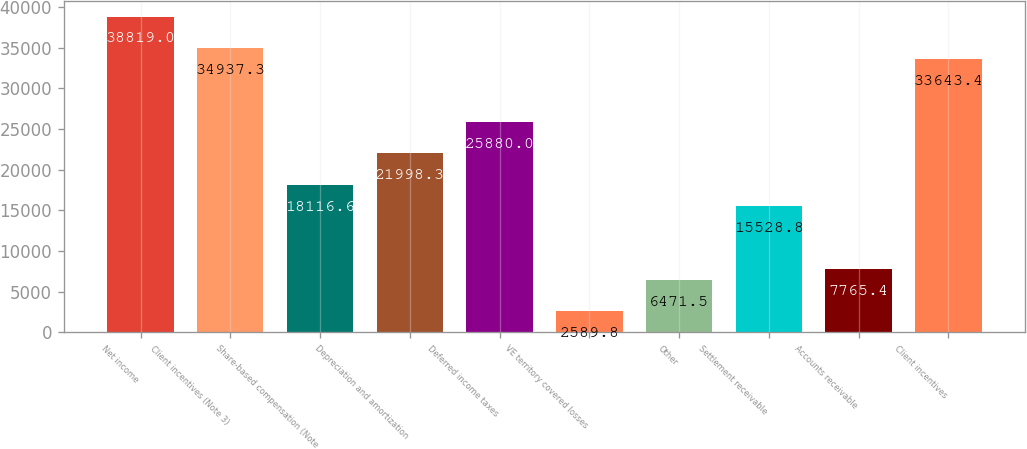Convert chart to OTSL. <chart><loc_0><loc_0><loc_500><loc_500><bar_chart><fcel>Net income<fcel>Client incentives (Note 3)<fcel>Share-based compensation (Note<fcel>Depreciation and amortization<fcel>Deferred income taxes<fcel>VE territory covered losses<fcel>Other<fcel>Settlement receivable<fcel>Accounts receivable<fcel>Client incentives<nl><fcel>38819<fcel>34937.3<fcel>18116.6<fcel>21998.3<fcel>25880<fcel>2589.8<fcel>6471.5<fcel>15528.8<fcel>7765.4<fcel>33643.4<nl></chart> 